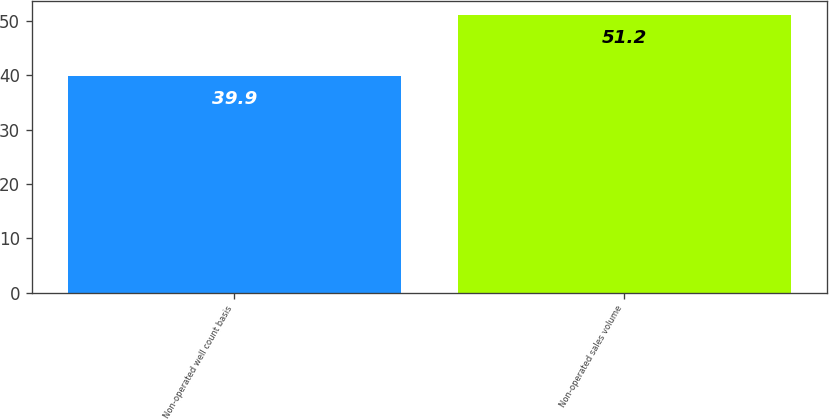Convert chart to OTSL. <chart><loc_0><loc_0><loc_500><loc_500><bar_chart><fcel>Non-operated well count basis<fcel>Non-operated sales volume<nl><fcel>39.9<fcel>51.2<nl></chart> 